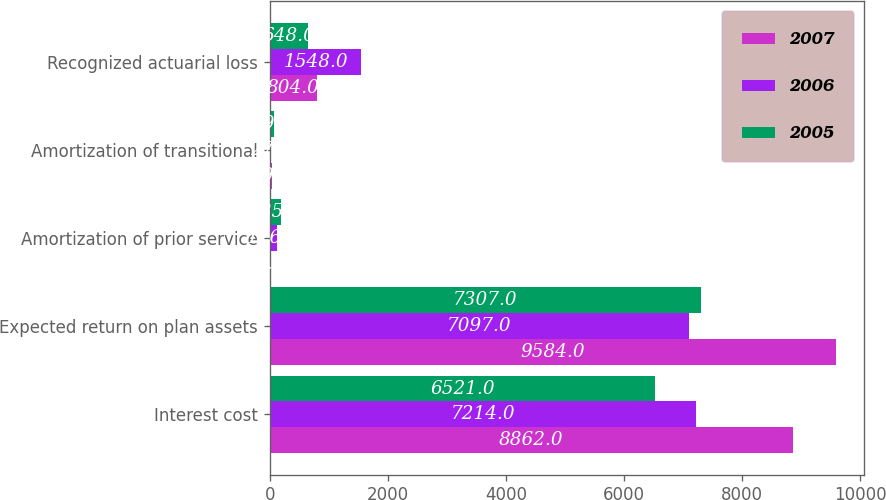Convert chart to OTSL. <chart><loc_0><loc_0><loc_500><loc_500><stacked_bar_chart><ecel><fcel>Interest cost<fcel>Expected return on plan assets<fcel>Amortization of prior service<fcel>Amortization of transitional<fcel>Recognized actuarial loss<nl><fcel>2007<fcel>8862<fcel>9584<fcel>8<fcel>39<fcel>804<nl><fcel>2006<fcel>7214<fcel>7097<fcel>116<fcel>27<fcel>1548<nl><fcel>2005<fcel>6521<fcel>7307<fcel>185<fcel>69<fcel>648<nl></chart> 